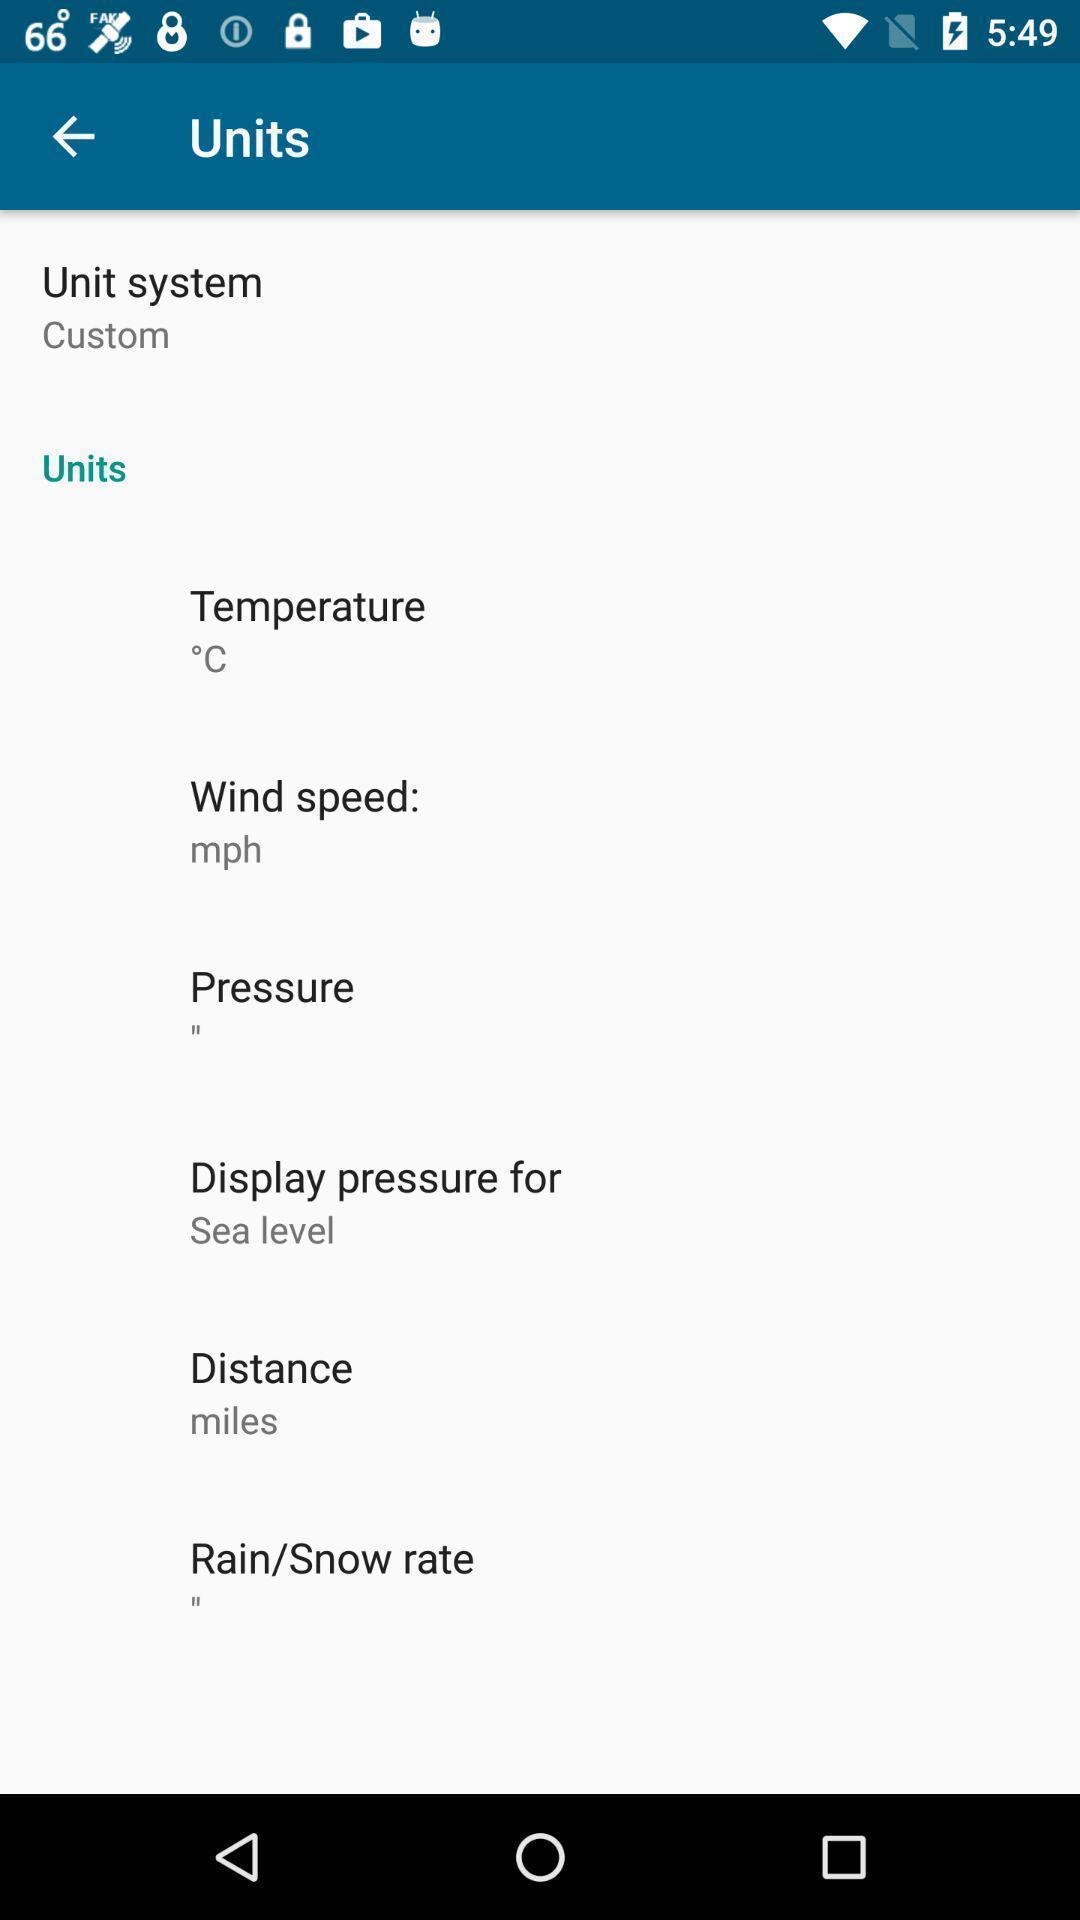Provide a textual representation of this image. Page displaying the units options. 